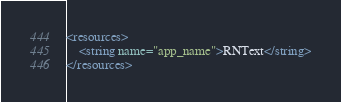<code> <loc_0><loc_0><loc_500><loc_500><_XML_><resources>
    <string name="app_name">RNText</string>
</resources>
</code> 